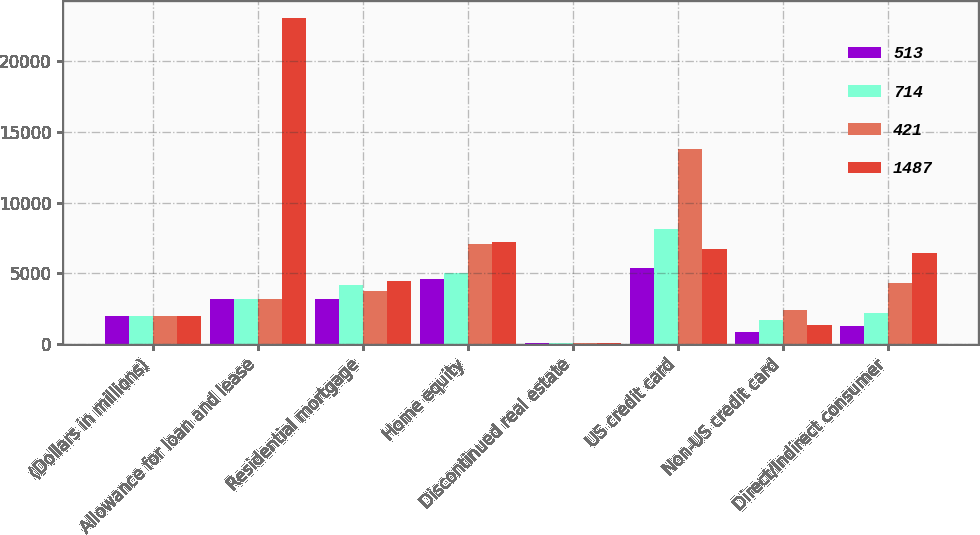Convert chart to OTSL. <chart><loc_0><loc_0><loc_500><loc_500><stacked_bar_chart><ecel><fcel>(Dollars in millions)<fcel>Allowance for loan and lease<fcel>Residential mortgage<fcel>Home equity<fcel>Discontinued real estate<fcel>US credit card<fcel>Non-US credit card<fcel>Direct/Indirect consumer<nl><fcel>513<fcel>2012<fcel>3211<fcel>3211<fcel>4566<fcel>72<fcel>5360<fcel>835<fcel>1258<nl><fcel>714<fcel>2011<fcel>3211<fcel>4195<fcel>4990<fcel>106<fcel>8114<fcel>1691<fcel>2190<nl><fcel>421<fcel>2010<fcel>3211<fcel>3779<fcel>7059<fcel>77<fcel>13818<fcel>2424<fcel>4303<nl><fcel>1487<fcel>2009<fcel>23071<fcel>4436<fcel>7205<fcel>104<fcel>6753<fcel>1332<fcel>6406<nl></chart> 